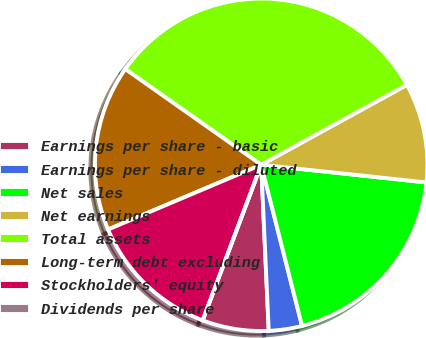Convert chart. <chart><loc_0><loc_0><loc_500><loc_500><pie_chart><fcel>Earnings per share - basic<fcel>Earnings per share - diluted<fcel>Net sales<fcel>Net earnings<fcel>Total assets<fcel>Long-term debt excluding<fcel>Stockholders' equity<fcel>Dividends per share<nl><fcel>6.45%<fcel>3.23%<fcel>19.35%<fcel>9.68%<fcel>32.25%<fcel>16.13%<fcel>12.9%<fcel>0.0%<nl></chart> 